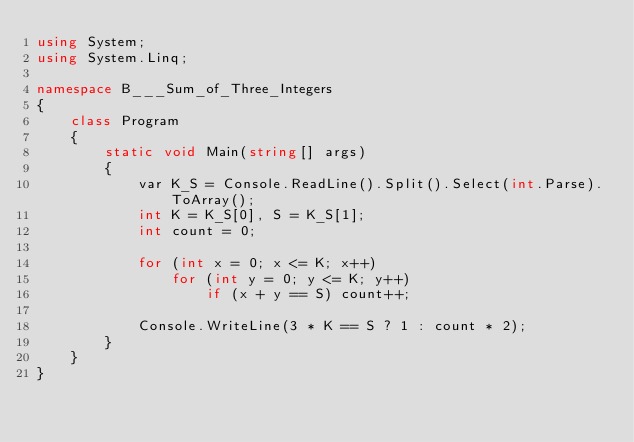Convert code to text. <code><loc_0><loc_0><loc_500><loc_500><_C#_>using System;
using System.Linq;

namespace B___Sum_of_Three_Integers
{
    class Program
    {
        static void Main(string[] args)
        {
            var K_S = Console.ReadLine().Split().Select(int.Parse).ToArray();
            int K = K_S[0], S = K_S[1];
            int count = 0;

            for (int x = 0; x <= K; x++)
                for (int y = 0; y <= K; y++)
                    if (x + y == S) count++;

            Console.WriteLine(3 * K == S ? 1 : count * 2);
        }
    }
}
</code> 